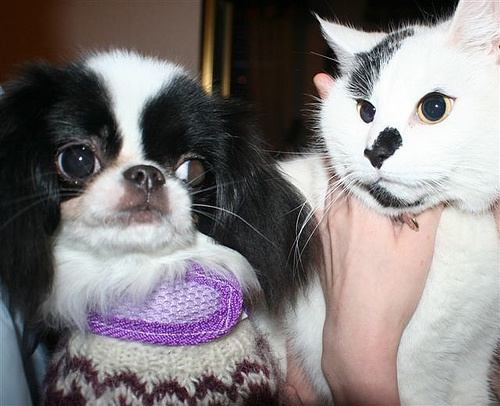Describe the objects in this image and their specific colors. I can see dog in black, lightgray, darkgray, and gray tones, cat in black, lightgray, darkgray, pink, and gray tones, and people in black, pink, and darkgray tones in this image. 